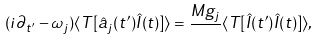Convert formula to latex. <formula><loc_0><loc_0><loc_500><loc_500>( i \partial _ { t ^ { \prime } } - \omega _ { j } ) \langle T [ \hat { a } _ { j } ( t ^ { \prime } ) \hat { I } ( t ) ] \rangle = \frac { M g _ { j } } { } \langle T [ \hat { I } ( t ^ { \prime } ) \hat { I } ( t ) ] \rangle ,</formula> 